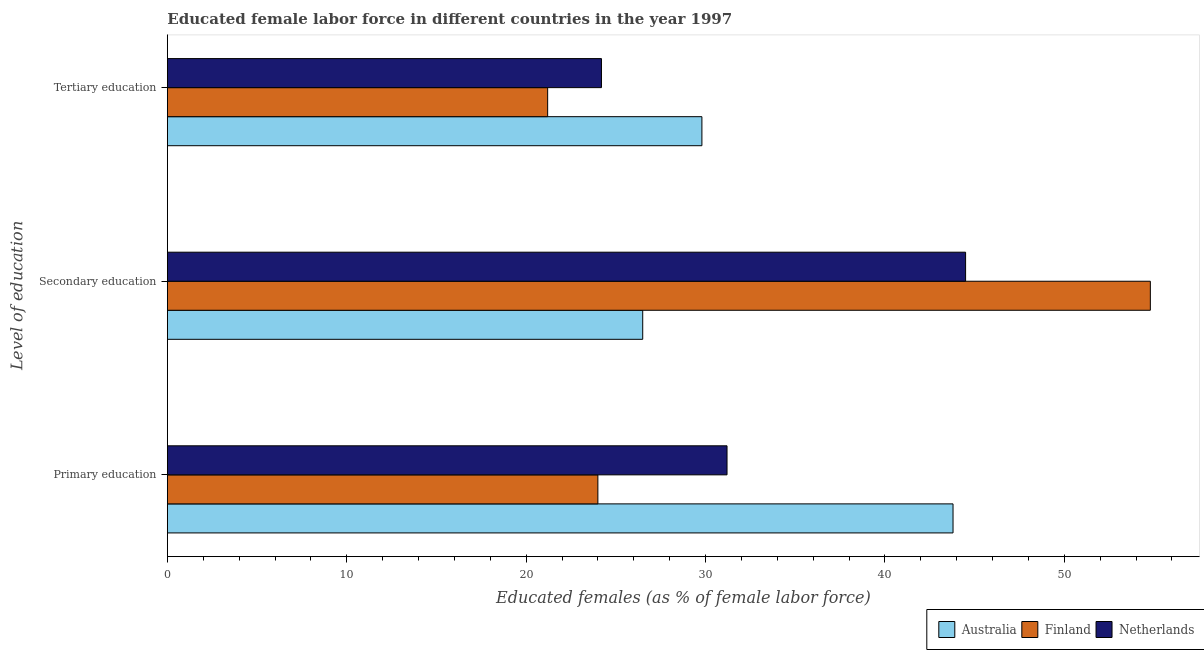How many different coloured bars are there?
Ensure brevity in your answer.  3. How many bars are there on the 3rd tick from the top?
Your response must be concise. 3. What is the label of the 3rd group of bars from the top?
Provide a short and direct response. Primary education. What is the percentage of female labor force who received tertiary education in Australia?
Your answer should be very brief. 29.8. Across all countries, what is the maximum percentage of female labor force who received tertiary education?
Give a very brief answer. 29.8. Across all countries, what is the minimum percentage of female labor force who received tertiary education?
Make the answer very short. 21.2. In which country was the percentage of female labor force who received primary education maximum?
Offer a terse response. Australia. In which country was the percentage of female labor force who received primary education minimum?
Ensure brevity in your answer.  Finland. What is the total percentage of female labor force who received tertiary education in the graph?
Give a very brief answer. 75.2. What is the difference between the percentage of female labor force who received secondary education in Australia and that in Finland?
Make the answer very short. -28.3. What is the difference between the percentage of female labor force who received tertiary education in Finland and the percentage of female labor force who received secondary education in Australia?
Provide a short and direct response. -5.3. What is the average percentage of female labor force who received primary education per country?
Ensure brevity in your answer.  33. What is the difference between the percentage of female labor force who received secondary education and percentage of female labor force who received primary education in Australia?
Make the answer very short. -17.3. In how many countries, is the percentage of female labor force who received primary education greater than 52 %?
Ensure brevity in your answer.  0. What is the ratio of the percentage of female labor force who received secondary education in Finland to that in Australia?
Your answer should be compact. 2.07. Is the difference between the percentage of female labor force who received primary education in Australia and Finland greater than the difference between the percentage of female labor force who received tertiary education in Australia and Finland?
Keep it short and to the point. Yes. What is the difference between the highest and the second highest percentage of female labor force who received tertiary education?
Provide a succinct answer. 5.6. What is the difference between the highest and the lowest percentage of female labor force who received primary education?
Your answer should be compact. 19.8. Is the sum of the percentage of female labor force who received secondary education in Netherlands and Australia greater than the maximum percentage of female labor force who received tertiary education across all countries?
Offer a very short reply. Yes. What does the 1st bar from the bottom in Secondary education represents?
Your answer should be compact. Australia. Is it the case that in every country, the sum of the percentage of female labor force who received primary education and percentage of female labor force who received secondary education is greater than the percentage of female labor force who received tertiary education?
Ensure brevity in your answer.  Yes. How many bars are there?
Give a very brief answer. 9. Are all the bars in the graph horizontal?
Provide a succinct answer. Yes. How many countries are there in the graph?
Provide a short and direct response. 3. What is the difference between two consecutive major ticks on the X-axis?
Ensure brevity in your answer.  10. Are the values on the major ticks of X-axis written in scientific E-notation?
Make the answer very short. No. Where does the legend appear in the graph?
Give a very brief answer. Bottom right. What is the title of the graph?
Your answer should be compact. Educated female labor force in different countries in the year 1997. What is the label or title of the X-axis?
Keep it short and to the point. Educated females (as % of female labor force). What is the label or title of the Y-axis?
Provide a short and direct response. Level of education. What is the Educated females (as % of female labor force) in Australia in Primary education?
Your answer should be very brief. 43.8. What is the Educated females (as % of female labor force) of Netherlands in Primary education?
Offer a terse response. 31.2. What is the Educated females (as % of female labor force) in Finland in Secondary education?
Offer a very short reply. 54.8. What is the Educated females (as % of female labor force) of Netherlands in Secondary education?
Give a very brief answer. 44.5. What is the Educated females (as % of female labor force) of Australia in Tertiary education?
Provide a succinct answer. 29.8. What is the Educated females (as % of female labor force) in Finland in Tertiary education?
Offer a very short reply. 21.2. What is the Educated females (as % of female labor force) of Netherlands in Tertiary education?
Offer a very short reply. 24.2. Across all Level of education, what is the maximum Educated females (as % of female labor force) of Australia?
Ensure brevity in your answer.  43.8. Across all Level of education, what is the maximum Educated females (as % of female labor force) of Finland?
Offer a very short reply. 54.8. Across all Level of education, what is the maximum Educated females (as % of female labor force) of Netherlands?
Provide a short and direct response. 44.5. Across all Level of education, what is the minimum Educated females (as % of female labor force) of Finland?
Ensure brevity in your answer.  21.2. Across all Level of education, what is the minimum Educated females (as % of female labor force) in Netherlands?
Your answer should be very brief. 24.2. What is the total Educated females (as % of female labor force) in Australia in the graph?
Provide a succinct answer. 100.1. What is the total Educated females (as % of female labor force) of Netherlands in the graph?
Make the answer very short. 99.9. What is the difference between the Educated females (as % of female labor force) in Finland in Primary education and that in Secondary education?
Keep it short and to the point. -30.8. What is the difference between the Educated females (as % of female labor force) of Netherlands in Primary education and that in Secondary education?
Provide a short and direct response. -13.3. What is the difference between the Educated females (as % of female labor force) in Finland in Secondary education and that in Tertiary education?
Give a very brief answer. 33.6. What is the difference between the Educated females (as % of female labor force) of Netherlands in Secondary education and that in Tertiary education?
Ensure brevity in your answer.  20.3. What is the difference between the Educated females (as % of female labor force) in Australia in Primary education and the Educated females (as % of female labor force) in Netherlands in Secondary education?
Keep it short and to the point. -0.7. What is the difference between the Educated females (as % of female labor force) in Finland in Primary education and the Educated females (as % of female labor force) in Netherlands in Secondary education?
Your answer should be compact. -20.5. What is the difference between the Educated females (as % of female labor force) in Australia in Primary education and the Educated females (as % of female labor force) in Finland in Tertiary education?
Provide a succinct answer. 22.6. What is the difference between the Educated females (as % of female labor force) in Australia in Primary education and the Educated females (as % of female labor force) in Netherlands in Tertiary education?
Offer a very short reply. 19.6. What is the difference between the Educated females (as % of female labor force) of Australia in Secondary education and the Educated females (as % of female labor force) of Netherlands in Tertiary education?
Your answer should be compact. 2.3. What is the difference between the Educated females (as % of female labor force) of Finland in Secondary education and the Educated females (as % of female labor force) of Netherlands in Tertiary education?
Provide a short and direct response. 30.6. What is the average Educated females (as % of female labor force) of Australia per Level of education?
Ensure brevity in your answer.  33.37. What is the average Educated females (as % of female labor force) in Finland per Level of education?
Offer a very short reply. 33.33. What is the average Educated females (as % of female labor force) of Netherlands per Level of education?
Your response must be concise. 33.3. What is the difference between the Educated females (as % of female labor force) in Australia and Educated females (as % of female labor force) in Finland in Primary education?
Your answer should be very brief. 19.8. What is the difference between the Educated females (as % of female labor force) in Finland and Educated females (as % of female labor force) in Netherlands in Primary education?
Your response must be concise. -7.2. What is the difference between the Educated females (as % of female labor force) in Australia and Educated females (as % of female labor force) in Finland in Secondary education?
Ensure brevity in your answer.  -28.3. What is the difference between the Educated females (as % of female labor force) in Australia and Educated females (as % of female labor force) in Netherlands in Secondary education?
Your response must be concise. -18. What is the difference between the Educated females (as % of female labor force) of Australia and Educated females (as % of female labor force) of Finland in Tertiary education?
Provide a short and direct response. 8.6. What is the difference between the Educated females (as % of female labor force) in Finland and Educated females (as % of female labor force) in Netherlands in Tertiary education?
Provide a short and direct response. -3. What is the ratio of the Educated females (as % of female labor force) of Australia in Primary education to that in Secondary education?
Ensure brevity in your answer.  1.65. What is the ratio of the Educated females (as % of female labor force) in Finland in Primary education to that in Secondary education?
Provide a succinct answer. 0.44. What is the ratio of the Educated females (as % of female labor force) of Netherlands in Primary education to that in Secondary education?
Provide a short and direct response. 0.7. What is the ratio of the Educated females (as % of female labor force) in Australia in Primary education to that in Tertiary education?
Offer a very short reply. 1.47. What is the ratio of the Educated females (as % of female labor force) in Finland in Primary education to that in Tertiary education?
Offer a terse response. 1.13. What is the ratio of the Educated females (as % of female labor force) in Netherlands in Primary education to that in Tertiary education?
Ensure brevity in your answer.  1.29. What is the ratio of the Educated females (as % of female labor force) in Australia in Secondary education to that in Tertiary education?
Your response must be concise. 0.89. What is the ratio of the Educated females (as % of female labor force) in Finland in Secondary education to that in Tertiary education?
Your response must be concise. 2.58. What is the ratio of the Educated females (as % of female labor force) of Netherlands in Secondary education to that in Tertiary education?
Give a very brief answer. 1.84. What is the difference between the highest and the second highest Educated females (as % of female labor force) of Australia?
Make the answer very short. 14. What is the difference between the highest and the second highest Educated females (as % of female labor force) of Finland?
Provide a succinct answer. 30.8. What is the difference between the highest and the second highest Educated females (as % of female labor force) in Netherlands?
Give a very brief answer. 13.3. What is the difference between the highest and the lowest Educated females (as % of female labor force) of Australia?
Your answer should be compact. 17.3. What is the difference between the highest and the lowest Educated females (as % of female labor force) of Finland?
Provide a succinct answer. 33.6. What is the difference between the highest and the lowest Educated females (as % of female labor force) in Netherlands?
Give a very brief answer. 20.3. 